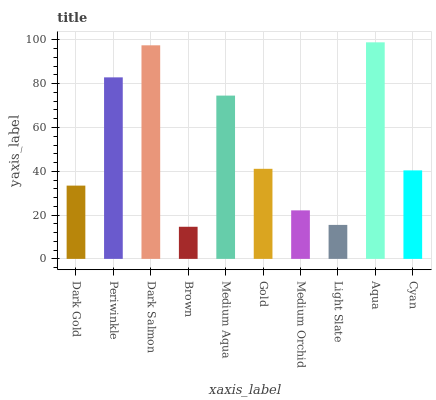Is Brown the minimum?
Answer yes or no. Yes. Is Aqua the maximum?
Answer yes or no. Yes. Is Periwinkle the minimum?
Answer yes or no. No. Is Periwinkle the maximum?
Answer yes or no. No. Is Periwinkle greater than Dark Gold?
Answer yes or no. Yes. Is Dark Gold less than Periwinkle?
Answer yes or no. Yes. Is Dark Gold greater than Periwinkle?
Answer yes or no. No. Is Periwinkle less than Dark Gold?
Answer yes or no. No. Is Gold the high median?
Answer yes or no. Yes. Is Cyan the low median?
Answer yes or no. Yes. Is Aqua the high median?
Answer yes or no. No. Is Gold the low median?
Answer yes or no. No. 